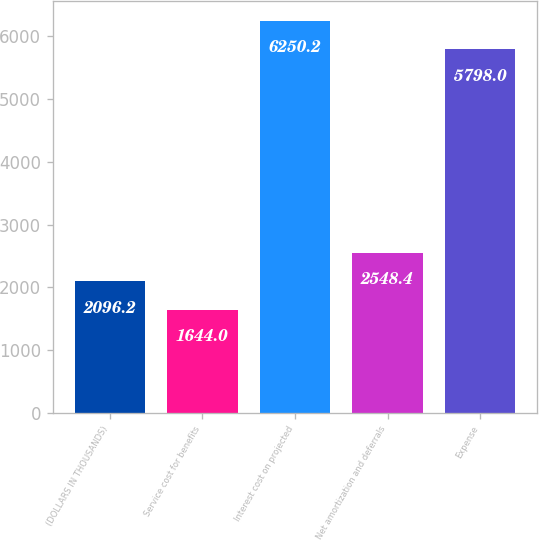<chart> <loc_0><loc_0><loc_500><loc_500><bar_chart><fcel>(DOLLARS IN THOUSANDS)<fcel>Service cost for benefits<fcel>Interest cost on projected<fcel>Net amortization and deferrals<fcel>Expense<nl><fcel>2096.2<fcel>1644<fcel>6250.2<fcel>2548.4<fcel>5798<nl></chart> 